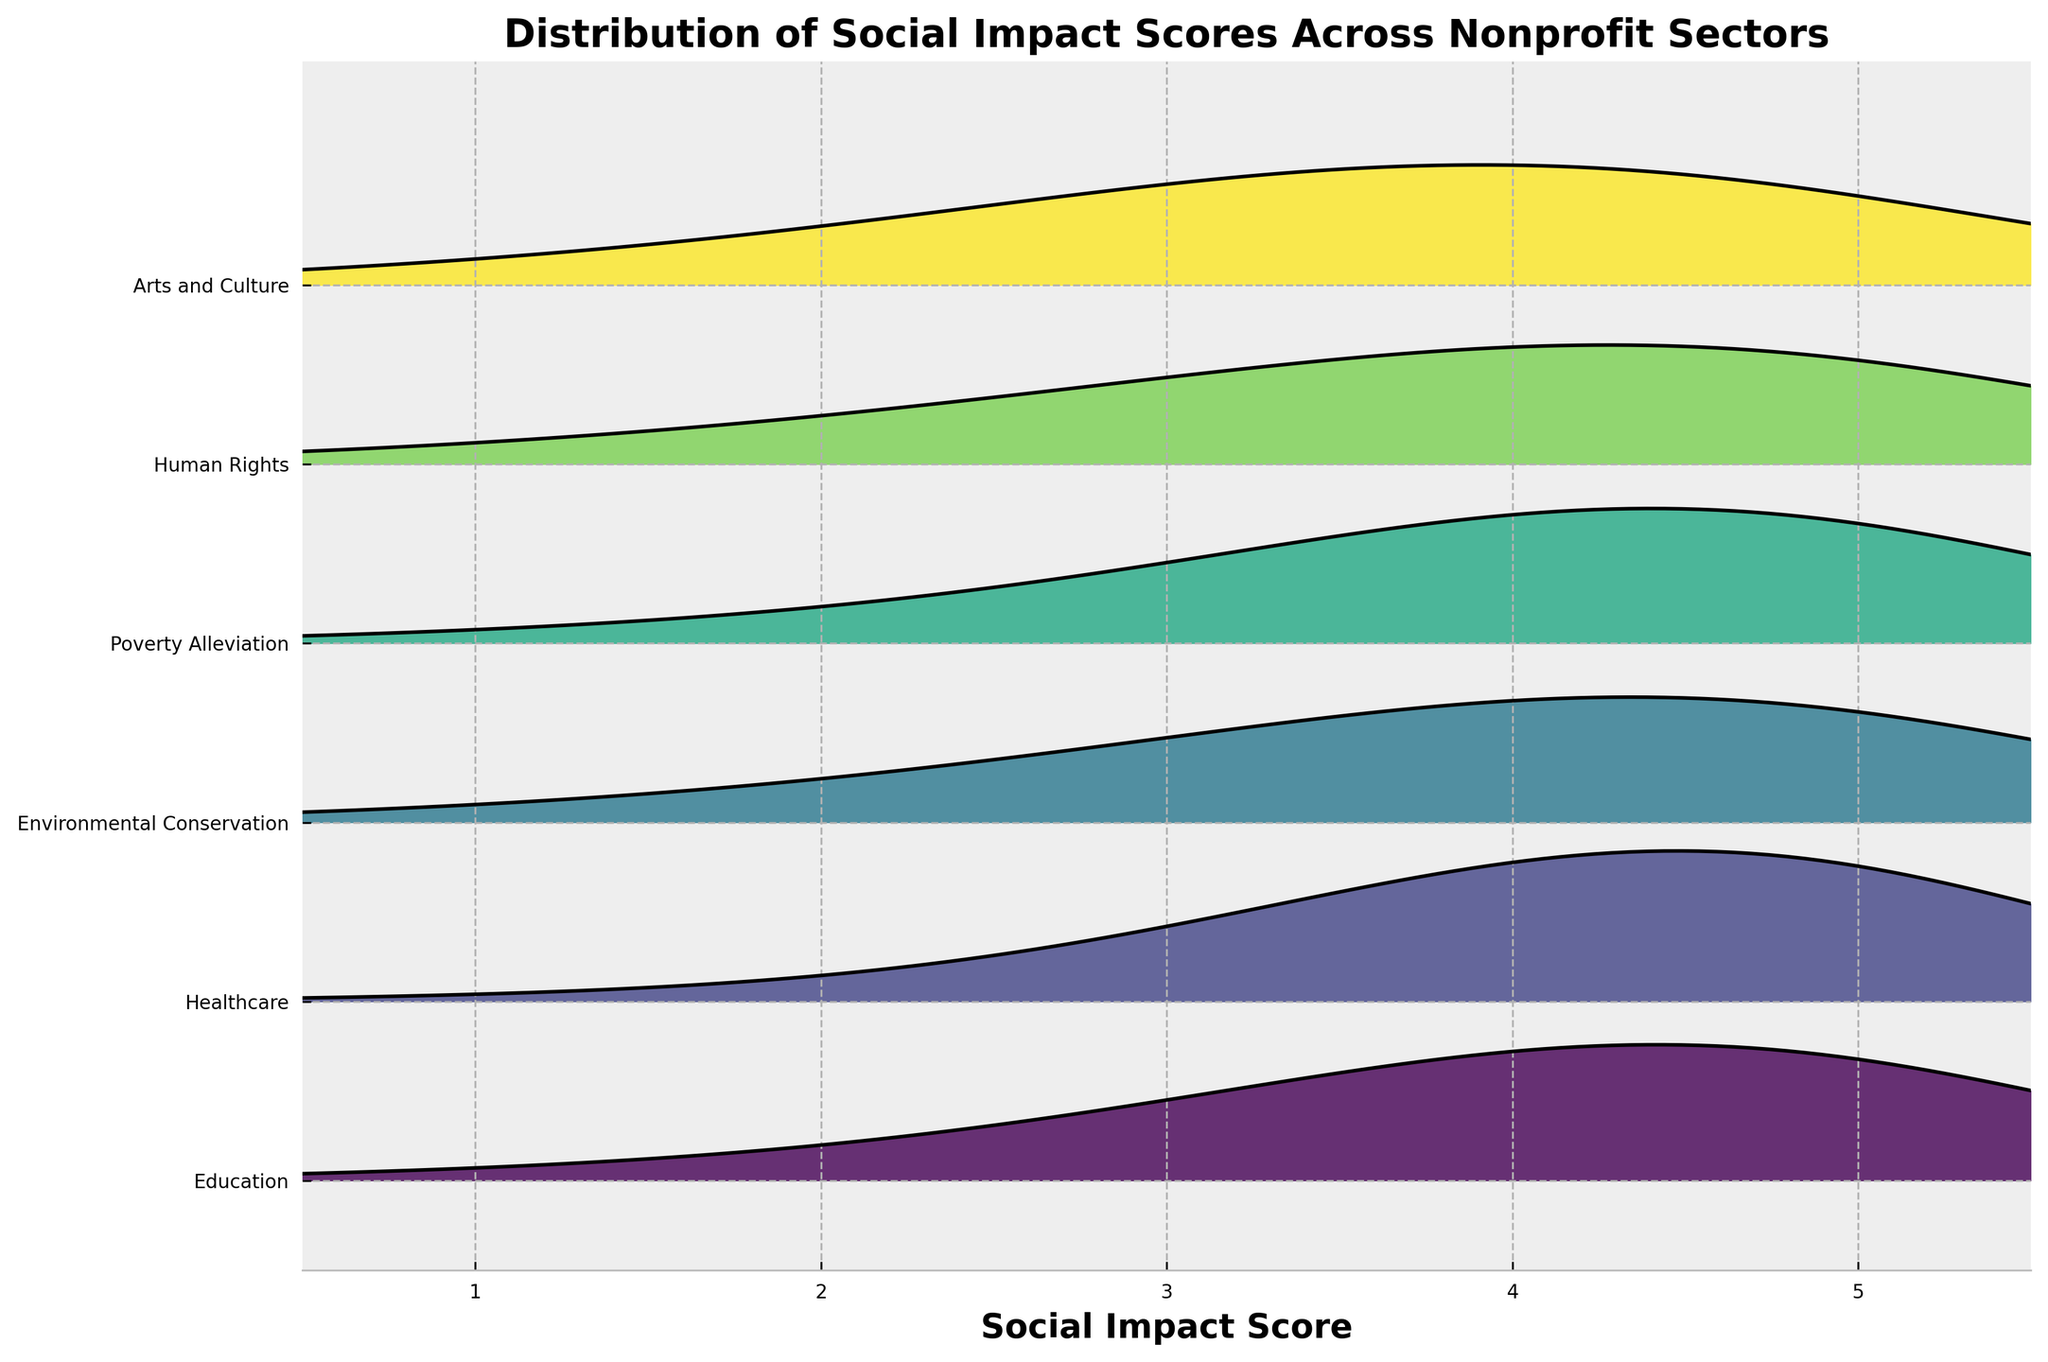What's the title of the figure? The title is located at the top of the figure.
Answer: Distribution of Social Impact Scores Across Nonprofit Sectors What is the sector with the highest density score at the impact level of 5? Observing the peak heights at score 5 for each sector, Healthcare has the highest density.
Answer: Healthcare Which sector shows the most balanced distribution of social impact scores? Arts and Culture has a more uniform distribution without a strong peak at any score, indicating a balanced distribution.
Answer: Arts and Culture At what impact score does Environmental Conservation sector reach its peak density? By looking at where the peak occurs in the Environmental Conservation density curve, it can be seen at a score of 5.
Answer: 5 Which sector has the least density at score 3? Comparing the heights of the density curves at score 3, Healthcare shows the least density.
Answer: Healthcare Are there any sectors with their highest density occurring at score 4? By observing the peaks of the various sectors, Education and Poverty Alleviation both have their highest density at score 4.
Answer: Education, Poverty Alleviation How do the peak densities of Human Rights and Arts and Culture at score 2 compare? Comparing the heights of the density curves of Human Rights and Arts and Culture at score 2, Human Rights has a higher peak density.
Answer: Human Rights Which sector has the widest range of scores with relatively high density (more than 0.3)? Analyzing the sectors, Arts and Culture maintains high densities (>0.3) over the entire range from score 2 to 4.
Answer: Arts and Culture How many sectors show a density greater than 0.4 at any impact score? By examining the peaks, three sectors (Education, Healthcare, and Environmental Conservation) show density greater than 0.4 at some scores.
Answer: Three Do any sectors have their highest density at impact score 1? Observing the highest points in density curves, none of the sectors have their peak density at score 1.
Answer: No 